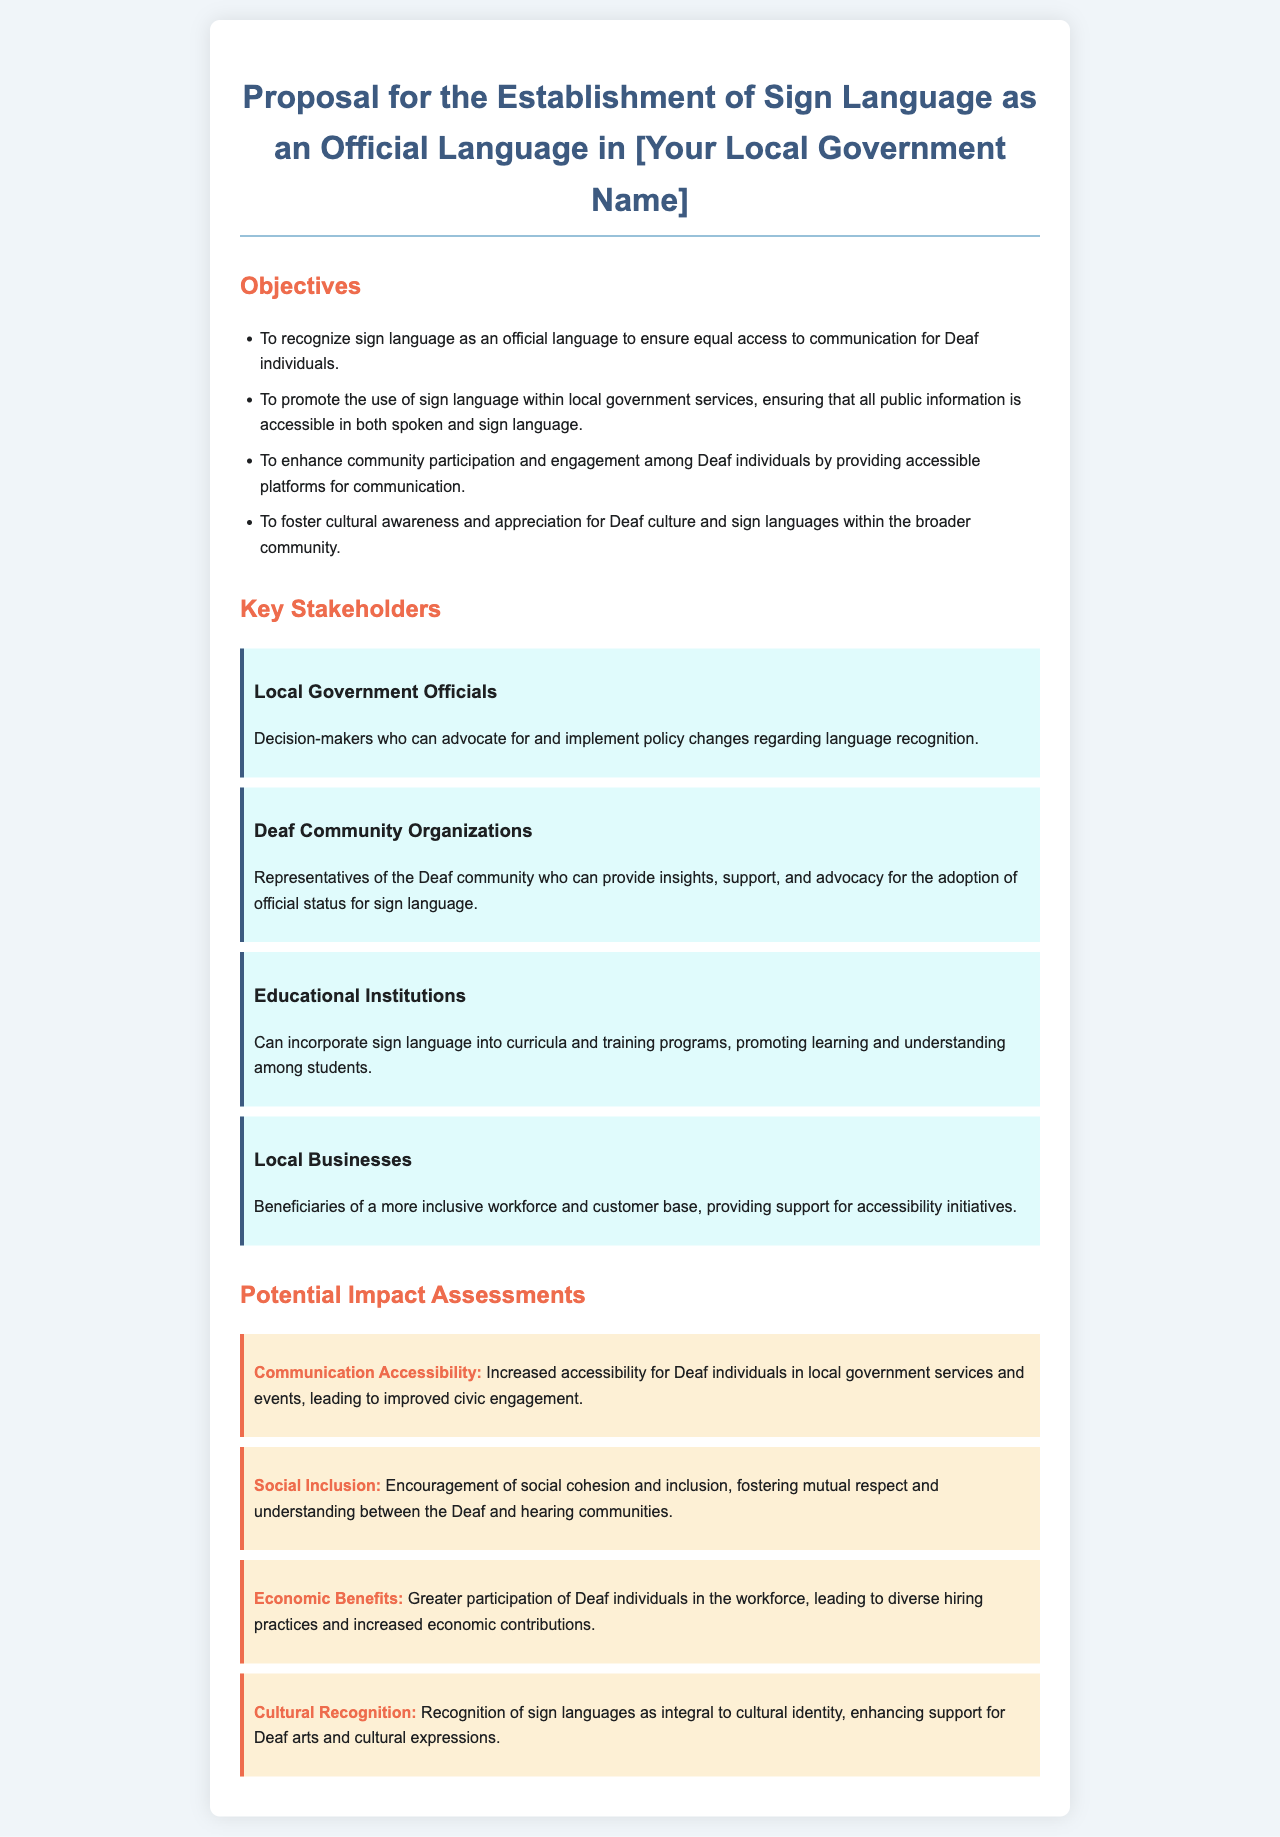What is the main title of the proposal? The main title of the proposal is found in the header of the document.
Answer: Proposal for the Establishment of Sign Language as an Official Language in [Your Local Government Name] How many main objectives are listed in the proposal? The number of objectives can be counted in the list under the "Objectives" section.
Answer: 4 Who are the representatives from the Deaf community mentioned as stakeholders? The stakeholders include various groups, specifically one representing the Deaf community.
Answer: Deaf Community Organizations What impact area focuses on economic contributions? The impact area that discusses economic aspects is listed under "Potential Impact Assessments".
Answer: Economic Benefits Which group can help promote sign language in educational settings? The group that can incorporate sign language into curricula is mentioned among the stakeholders.
Answer: Educational Institutions What does the objective aimed at community engagement mention? The objective describes enhancing participation through accessible communication.
Answer: Community participation and engagement What is one potential impact of recognizing sign language? The document lists several impacts, one of which relates to social inclusion.
Answer: Social Inclusion 